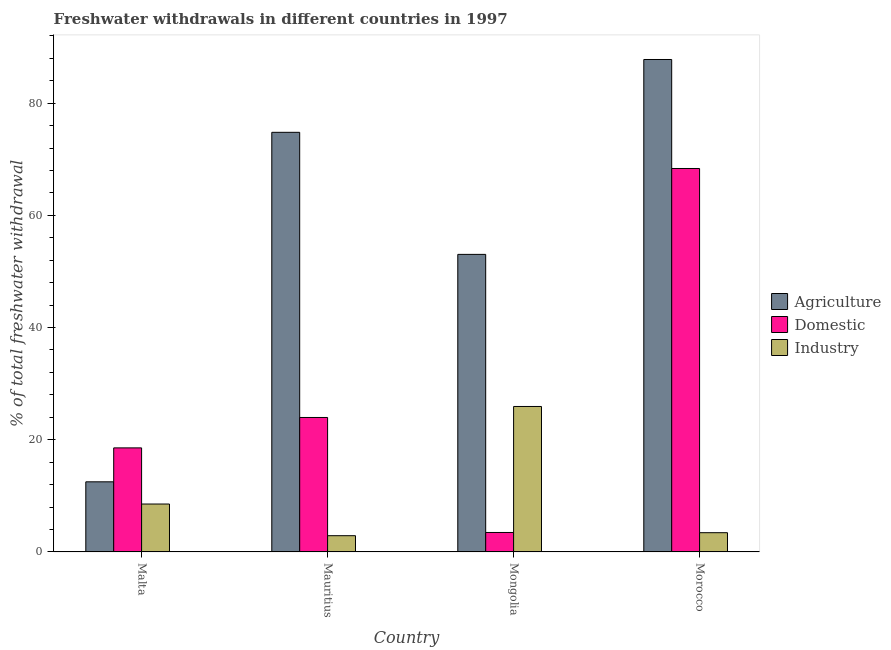How many different coloured bars are there?
Your answer should be very brief. 3. What is the label of the 3rd group of bars from the left?
Ensure brevity in your answer.  Mongolia. In how many cases, is the number of bars for a given country not equal to the number of legend labels?
Give a very brief answer. 0. What is the percentage of freshwater withdrawal for industry in Malta?
Keep it short and to the point. 8.54. Across all countries, what is the maximum percentage of freshwater withdrawal for domestic purposes?
Offer a terse response. 68.35. Across all countries, what is the minimum percentage of freshwater withdrawal for agriculture?
Offer a terse response. 12.5. In which country was the percentage of freshwater withdrawal for domestic purposes maximum?
Make the answer very short. Morocco. In which country was the percentage of freshwater withdrawal for industry minimum?
Give a very brief answer. Mauritius. What is the total percentage of freshwater withdrawal for domestic purposes in the graph?
Your answer should be very brief. 114.34. What is the difference between the percentage of freshwater withdrawal for domestic purposes in Malta and that in Morocco?
Keep it short and to the point. -49.8. What is the difference between the percentage of freshwater withdrawal for domestic purposes in Malta and the percentage of freshwater withdrawal for industry in Mongolia?
Provide a short and direct response. -7.38. What is the average percentage of freshwater withdrawal for domestic purposes per country?
Your answer should be compact. 28.59. What is the difference between the percentage of freshwater withdrawal for agriculture and percentage of freshwater withdrawal for industry in Morocco?
Your response must be concise. 84.35. In how many countries, is the percentage of freshwater withdrawal for industry greater than 8 %?
Your response must be concise. 2. What is the ratio of the percentage of freshwater withdrawal for industry in Malta to that in Mauritius?
Your response must be concise. 2.95. Is the percentage of freshwater withdrawal for agriculture in Malta less than that in Mongolia?
Make the answer very short. Yes. What is the difference between the highest and the second highest percentage of freshwater withdrawal for industry?
Your response must be concise. 17.39. What is the difference between the highest and the lowest percentage of freshwater withdrawal for agriculture?
Your response must be concise. 75.28. What does the 3rd bar from the left in Morocco represents?
Give a very brief answer. Industry. What does the 3rd bar from the right in Malta represents?
Give a very brief answer. Agriculture. How many bars are there?
Ensure brevity in your answer.  12. Are the values on the major ticks of Y-axis written in scientific E-notation?
Provide a short and direct response. No. Does the graph contain grids?
Ensure brevity in your answer.  No. Where does the legend appear in the graph?
Ensure brevity in your answer.  Center right. What is the title of the graph?
Your answer should be very brief. Freshwater withdrawals in different countries in 1997. What is the label or title of the X-axis?
Offer a very short reply. Country. What is the label or title of the Y-axis?
Keep it short and to the point. % of total freshwater withdrawal. What is the % of total freshwater withdrawal of Domestic in Malta?
Your answer should be very brief. 18.55. What is the % of total freshwater withdrawal of Industry in Malta?
Your response must be concise. 8.54. What is the % of total freshwater withdrawal of Agriculture in Mauritius?
Your response must be concise. 74.8. What is the % of total freshwater withdrawal of Domestic in Mauritius?
Your response must be concise. 23.97. What is the % of total freshwater withdrawal in Industry in Mauritius?
Provide a succinct answer. 2.9. What is the % of total freshwater withdrawal of Agriculture in Mongolia?
Offer a very short reply. 53.04. What is the % of total freshwater withdrawal in Domestic in Mongolia?
Make the answer very short. 3.47. What is the % of total freshwater withdrawal in Industry in Mongolia?
Ensure brevity in your answer.  25.93. What is the % of total freshwater withdrawal of Agriculture in Morocco?
Make the answer very short. 87.78. What is the % of total freshwater withdrawal of Domestic in Morocco?
Keep it short and to the point. 68.35. What is the % of total freshwater withdrawal in Industry in Morocco?
Provide a succinct answer. 3.43. Across all countries, what is the maximum % of total freshwater withdrawal of Agriculture?
Offer a very short reply. 87.78. Across all countries, what is the maximum % of total freshwater withdrawal of Domestic?
Provide a short and direct response. 68.35. Across all countries, what is the maximum % of total freshwater withdrawal in Industry?
Ensure brevity in your answer.  25.93. Across all countries, what is the minimum % of total freshwater withdrawal in Agriculture?
Your response must be concise. 12.5. Across all countries, what is the minimum % of total freshwater withdrawal in Domestic?
Provide a short and direct response. 3.47. Across all countries, what is the minimum % of total freshwater withdrawal in Industry?
Offer a terse response. 2.9. What is the total % of total freshwater withdrawal in Agriculture in the graph?
Provide a short and direct response. 228.12. What is the total % of total freshwater withdrawal in Domestic in the graph?
Offer a very short reply. 114.34. What is the total % of total freshwater withdrawal in Industry in the graph?
Provide a succinct answer. 40.8. What is the difference between the % of total freshwater withdrawal in Agriculture in Malta and that in Mauritius?
Your response must be concise. -62.3. What is the difference between the % of total freshwater withdrawal of Domestic in Malta and that in Mauritius?
Your response must be concise. -5.42. What is the difference between the % of total freshwater withdrawal of Industry in Malta and that in Mauritius?
Offer a very short reply. 5.65. What is the difference between the % of total freshwater withdrawal in Agriculture in Malta and that in Mongolia?
Offer a very short reply. -40.54. What is the difference between the % of total freshwater withdrawal of Domestic in Malta and that in Mongolia?
Keep it short and to the point. 15.08. What is the difference between the % of total freshwater withdrawal in Industry in Malta and that in Mongolia?
Ensure brevity in your answer.  -17.39. What is the difference between the % of total freshwater withdrawal in Agriculture in Malta and that in Morocco?
Ensure brevity in your answer.  -75.28. What is the difference between the % of total freshwater withdrawal of Domestic in Malta and that in Morocco?
Give a very brief answer. -49.8. What is the difference between the % of total freshwater withdrawal of Industry in Malta and that in Morocco?
Give a very brief answer. 5.11. What is the difference between the % of total freshwater withdrawal of Agriculture in Mauritius and that in Mongolia?
Your answer should be compact. 21.76. What is the difference between the % of total freshwater withdrawal in Domestic in Mauritius and that in Mongolia?
Offer a very short reply. 20.5. What is the difference between the % of total freshwater withdrawal of Industry in Mauritius and that in Mongolia?
Your answer should be compact. -23.03. What is the difference between the % of total freshwater withdrawal of Agriculture in Mauritius and that in Morocco?
Your response must be concise. -12.98. What is the difference between the % of total freshwater withdrawal in Domestic in Mauritius and that in Morocco?
Your response must be concise. -44.38. What is the difference between the % of total freshwater withdrawal in Industry in Mauritius and that in Morocco?
Your answer should be very brief. -0.53. What is the difference between the % of total freshwater withdrawal of Agriculture in Mongolia and that in Morocco?
Give a very brief answer. -34.74. What is the difference between the % of total freshwater withdrawal in Domestic in Mongolia and that in Morocco?
Ensure brevity in your answer.  -64.88. What is the difference between the % of total freshwater withdrawal in Agriculture in Malta and the % of total freshwater withdrawal in Domestic in Mauritius?
Give a very brief answer. -11.47. What is the difference between the % of total freshwater withdrawal of Agriculture in Malta and the % of total freshwater withdrawal of Industry in Mauritius?
Offer a terse response. 9.6. What is the difference between the % of total freshwater withdrawal in Domestic in Malta and the % of total freshwater withdrawal in Industry in Mauritius?
Give a very brief answer. 15.65. What is the difference between the % of total freshwater withdrawal of Agriculture in Malta and the % of total freshwater withdrawal of Domestic in Mongolia?
Ensure brevity in your answer.  9.03. What is the difference between the % of total freshwater withdrawal of Agriculture in Malta and the % of total freshwater withdrawal of Industry in Mongolia?
Your response must be concise. -13.43. What is the difference between the % of total freshwater withdrawal of Domestic in Malta and the % of total freshwater withdrawal of Industry in Mongolia?
Offer a very short reply. -7.38. What is the difference between the % of total freshwater withdrawal in Agriculture in Malta and the % of total freshwater withdrawal in Domestic in Morocco?
Provide a short and direct response. -55.85. What is the difference between the % of total freshwater withdrawal in Agriculture in Malta and the % of total freshwater withdrawal in Industry in Morocco?
Keep it short and to the point. 9.07. What is the difference between the % of total freshwater withdrawal in Domestic in Malta and the % of total freshwater withdrawal in Industry in Morocco?
Offer a terse response. 15.12. What is the difference between the % of total freshwater withdrawal of Agriculture in Mauritius and the % of total freshwater withdrawal of Domestic in Mongolia?
Your response must be concise. 71.33. What is the difference between the % of total freshwater withdrawal in Agriculture in Mauritius and the % of total freshwater withdrawal in Industry in Mongolia?
Give a very brief answer. 48.87. What is the difference between the % of total freshwater withdrawal in Domestic in Mauritius and the % of total freshwater withdrawal in Industry in Mongolia?
Provide a succinct answer. -1.96. What is the difference between the % of total freshwater withdrawal in Agriculture in Mauritius and the % of total freshwater withdrawal in Domestic in Morocco?
Provide a short and direct response. 6.45. What is the difference between the % of total freshwater withdrawal in Agriculture in Mauritius and the % of total freshwater withdrawal in Industry in Morocco?
Your answer should be very brief. 71.37. What is the difference between the % of total freshwater withdrawal in Domestic in Mauritius and the % of total freshwater withdrawal in Industry in Morocco?
Provide a succinct answer. 20.54. What is the difference between the % of total freshwater withdrawal of Agriculture in Mongolia and the % of total freshwater withdrawal of Domestic in Morocco?
Ensure brevity in your answer.  -15.31. What is the difference between the % of total freshwater withdrawal in Agriculture in Mongolia and the % of total freshwater withdrawal in Industry in Morocco?
Your response must be concise. 49.61. What is the difference between the % of total freshwater withdrawal in Domestic in Mongolia and the % of total freshwater withdrawal in Industry in Morocco?
Make the answer very short. 0.04. What is the average % of total freshwater withdrawal of Agriculture per country?
Provide a succinct answer. 57.03. What is the average % of total freshwater withdrawal in Domestic per country?
Provide a succinct answer. 28.59. What is the difference between the % of total freshwater withdrawal in Agriculture and % of total freshwater withdrawal in Domestic in Malta?
Offer a very short reply. -6.05. What is the difference between the % of total freshwater withdrawal of Agriculture and % of total freshwater withdrawal of Industry in Malta?
Keep it short and to the point. 3.96. What is the difference between the % of total freshwater withdrawal of Domestic and % of total freshwater withdrawal of Industry in Malta?
Your answer should be very brief. 10.01. What is the difference between the % of total freshwater withdrawal of Agriculture and % of total freshwater withdrawal of Domestic in Mauritius?
Offer a very short reply. 50.83. What is the difference between the % of total freshwater withdrawal of Agriculture and % of total freshwater withdrawal of Industry in Mauritius?
Offer a very short reply. 71.9. What is the difference between the % of total freshwater withdrawal of Domestic and % of total freshwater withdrawal of Industry in Mauritius?
Your answer should be compact. 21.07. What is the difference between the % of total freshwater withdrawal in Agriculture and % of total freshwater withdrawal in Domestic in Mongolia?
Provide a short and direct response. 49.57. What is the difference between the % of total freshwater withdrawal in Agriculture and % of total freshwater withdrawal in Industry in Mongolia?
Give a very brief answer. 27.11. What is the difference between the % of total freshwater withdrawal in Domestic and % of total freshwater withdrawal in Industry in Mongolia?
Offer a terse response. -22.46. What is the difference between the % of total freshwater withdrawal in Agriculture and % of total freshwater withdrawal in Domestic in Morocco?
Give a very brief answer. 19.43. What is the difference between the % of total freshwater withdrawal in Agriculture and % of total freshwater withdrawal in Industry in Morocco?
Ensure brevity in your answer.  84.35. What is the difference between the % of total freshwater withdrawal in Domestic and % of total freshwater withdrawal in Industry in Morocco?
Your answer should be compact. 64.92. What is the ratio of the % of total freshwater withdrawal of Agriculture in Malta to that in Mauritius?
Your answer should be very brief. 0.17. What is the ratio of the % of total freshwater withdrawal in Domestic in Malta to that in Mauritius?
Your response must be concise. 0.77. What is the ratio of the % of total freshwater withdrawal in Industry in Malta to that in Mauritius?
Your answer should be compact. 2.95. What is the ratio of the % of total freshwater withdrawal in Agriculture in Malta to that in Mongolia?
Provide a short and direct response. 0.24. What is the ratio of the % of total freshwater withdrawal of Domestic in Malta to that in Mongolia?
Provide a succinct answer. 5.34. What is the ratio of the % of total freshwater withdrawal of Industry in Malta to that in Mongolia?
Offer a very short reply. 0.33. What is the ratio of the % of total freshwater withdrawal of Agriculture in Malta to that in Morocco?
Your answer should be compact. 0.14. What is the ratio of the % of total freshwater withdrawal of Domestic in Malta to that in Morocco?
Your response must be concise. 0.27. What is the ratio of the % of total freshwater withdrawal of Industry in Malta to that in Morocco?
Keep it short and to the point. 2.49. What is the ratio of the % of total freshwater withdrawal of Agriculture in Mauritius to that in Mongolia?
Make the answer very short. 1.41. What is the ratio of the % of total freshwater withdrawal in Domestic in Mauritius to that in Mongolia?
Provide a succinct answer. 6.91. What is the ratio of the % of total freshwater withdrawal of Industry in Mauritius to that in Mongolia?
Make the answer very short. 0.11. What is the ratio of the % of total freshwater withdrawal of Agriculture in Mauritius to that in Morocco?
Your answer should be compact. 0.85. What is the ratio of the % of total freshwater withdrawal of Domestic in Mauritius to that in Morocco?
Your response must be concise. 0.35. What is the ratio of the % of total freshwater withdrawal of Industry in Mauritius to that in Morocco?
Your answer should be compact. 0.84. What is the ratio of the % of total freshwater withdrawal of Agriculture in Mongolia to that in Morocco?
Give a very brief answer. 0.6. What is the ratio of the % of total freshwater withdrawal in Domestic in Mongolia to that in Morocco?
Give a very brief answer. 0.05. What is the ratio of the % of total freshwater withdrawal of Industry in Mongolia to that in Morocco?
Your response must be concise. 7.56. What is the difference between the highest and the second highest % of total freshwater withdrawal in Agriculture?
Ensure brevity in your answer.  12.98. What is the difference between the highest and the second highest % of total freshwater withdrawal in Domestic?
Keep it short and to the point. 44.38. What is the difference between the highest and the second highest % of total freshwater withdrawal of Industry?
Offer a very short reply. 17.39. What is the difference between the highest and the lowest % of total freshwater withdrawal of Agriculture?
Keep it short and to the point. 75.28. What is the difference between the highest and the lowest % of total freshwater withdrawal in Domestic?
Your answer should be very brief. 64.88. What is the difference between the highest and the lowest % of total freshwater withdrawal of Industry?
Give a very brief answer. 23.03. 